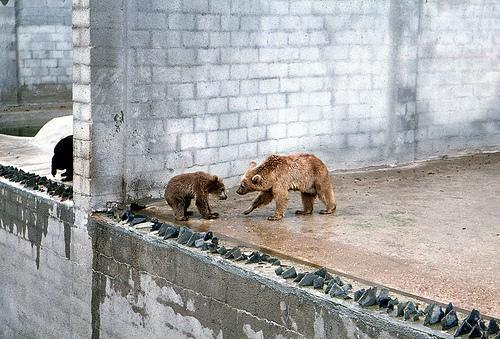How many bears are there?
Give a very brief answer. 2. 